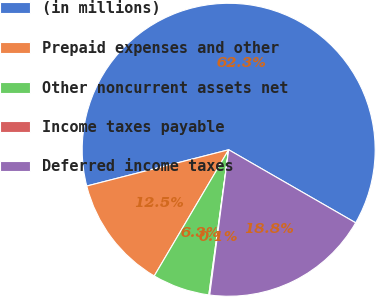Convert chart. <chart><loc_0><loc_0><loc_500><loc_500><pie_chart><fcel>(in millions)<fcel>Prepaid expenses and other<fcel>Other noncurrent assets net<fcel>Income taxes payable<fcel>Deferred income taxes<nl><fcel>62.3%<fcel>12.54%<fcel>6.32%<fcel>0.1%<fcel>18.76%<nl></chart> 